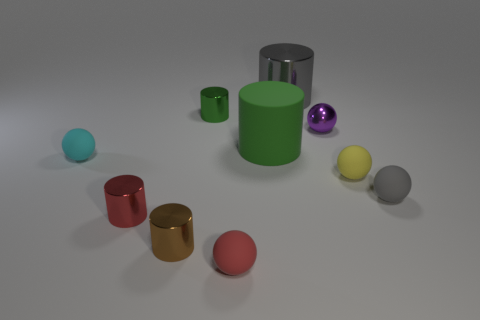What shape is the tiny matte object to the left of the tiny red thing in front of the tiny brown metal thing?
Offer a terse response. Sphere. There is a gray thing that is behind the tiny gray rubber object; does it have the same size as the yellow sphere to the right of the tiny green metal object?
Your answer should be very brief. No. Is there a small green cylinder that has the same material as the tiny red ball?
Keep it short and to the point. No. There is a shiny thing that is the same color as the large rubber thing; what is its size?
Keep it short and to the point. Small. There is a small rubber thing in front of the gray object in front of the big gray cylinder; is there a small shiny object that is to the left of it?
Offer a very short reply. Yes. There is a tiny metal ball; are there any big things in front of it?
Ensure brevity in your answer.  Yes. How many small red rubber balls are left of the purple sphere on the right side of the gray cylinder?
Your answer should be compact. 1. Do the brown thing and the red thing that is to the right of the brown cylinder have the same size?
Give a very brief answer. Yes. Are there any tiny cylinders of the same color as the big metallic object?
Provide a short and direct response. No. There is a red sphere that is made of the same material as the small yellow object; what size is it?
Your answer should be compact. Small. 